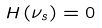<formula> <loc_0><loc_0><loc_500><loc_500>H \left ( \nu _ { s } \right ) = 0</formula> 